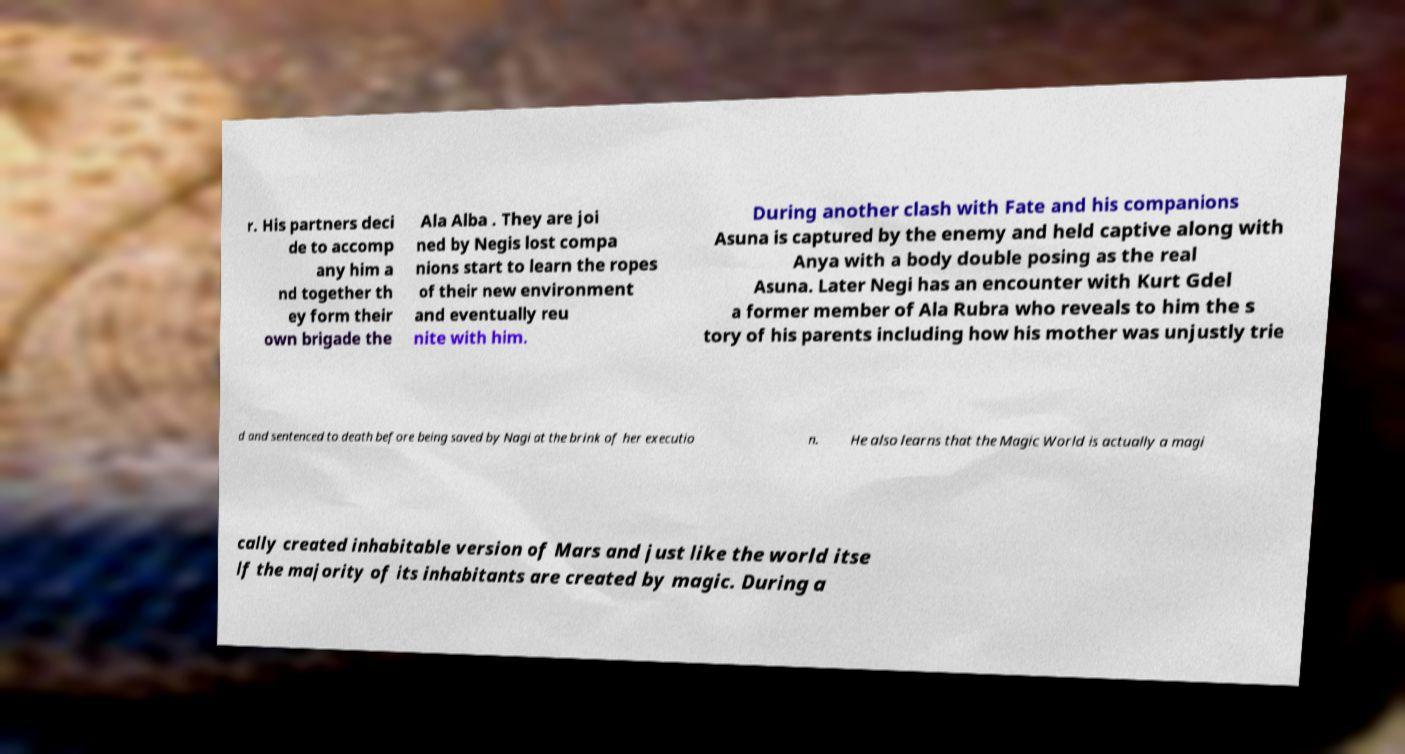There's text embedded in this image that I need extracted. Can you transcribe it verbatim? r. His partners deci de to accomp any him a nd together th ey form their own brigade the Ala Alba . They are joi ned by Negis lost compa nions start to learn the ropes of their new environment and eventually reu nite with him. During another clash with Fate and his companions Asuna is captured by the enemy and held captive along with Anya with a body double posing as the real Asuna. Later Negi has an encounter with Kurt Gdel a former member of Ala Rubra who reveals to him the s tory of his parents including how his mother was unjustly trie d and sentenced to death before being saved by Nagi at the brink of her executio n. He also learns that the Magic World is actually a magi cally created inhabitable version of Mars and just like the world itse lf the majority of its inhabitants are created by magic. During a 